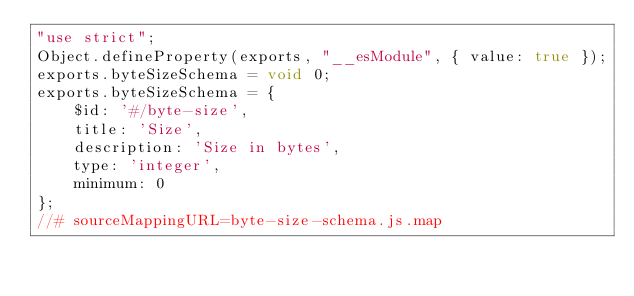<code> <loc_0><loc_0><loc_500><loc_500><_JavaScript_>"use strict";
Object.defineProperty(exports, "__esModule", { value: true });
exports.byteSizeSchema = void 0;
exports.byteSizeSchema = {
    $id: '#/byte-size',
    title: 'Size',
    description: 'Size in bytes',
    type: 'integer',
    minimum: 0
};
//# sourceMappingURL=byte-size-schema.js.map</code> 